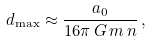<formula> <loc_0><loc_0><loc_500><loc_500>d _ { \max } \approx \frac { a _ { 0 } } { 1 6 \pi \, G \, m \, n } \, ,</formula> 